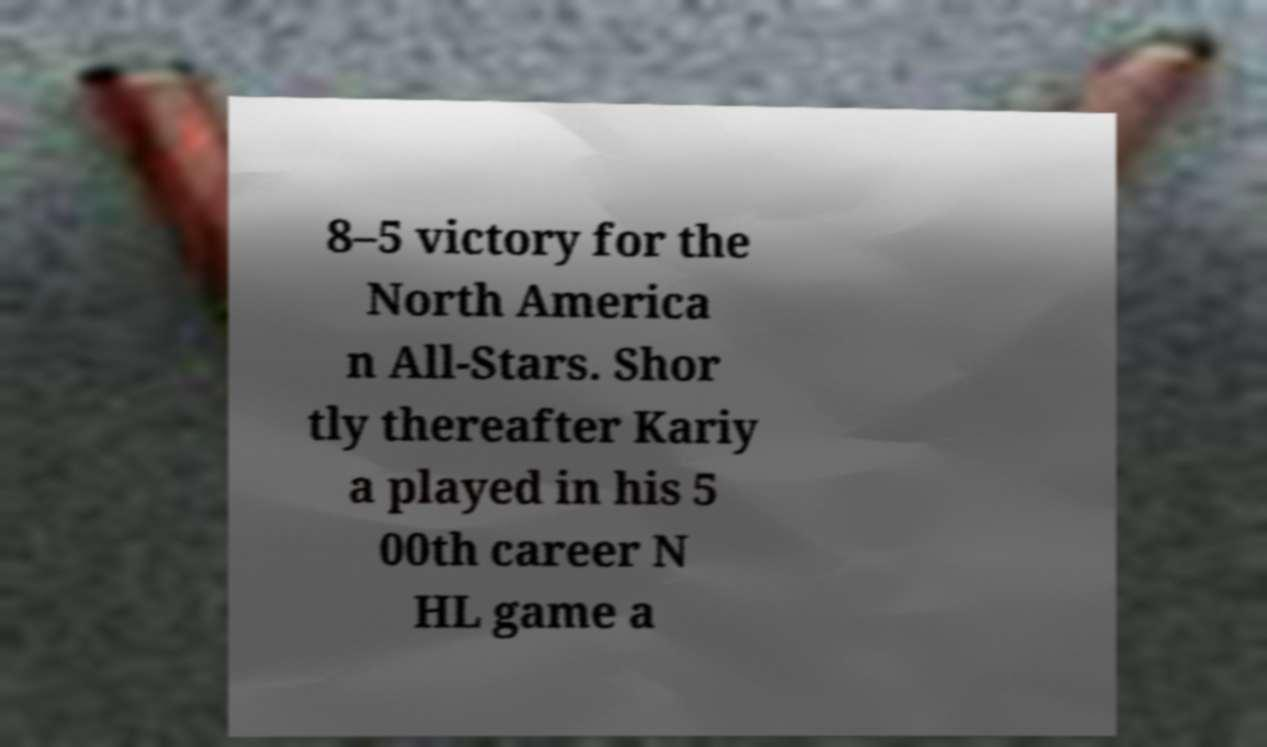Could you assist in decoding the text presented in this image and type it out clearly? 8–5 victory for the North America n All-Stars. Shor tly thereafter Kariy a played in his 5 00th career N HL game a 